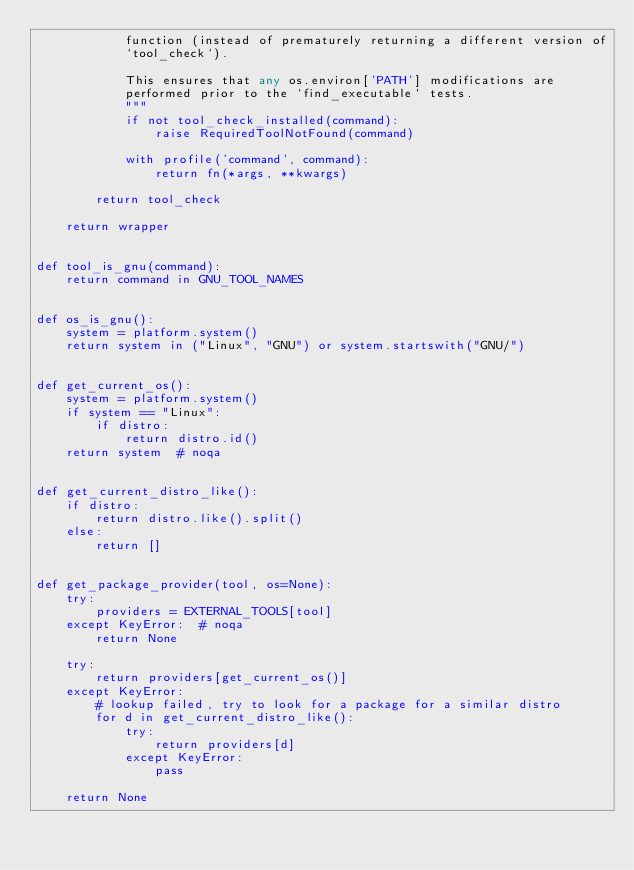Convert code to text. <code><loc_0><loc_0><loc_500><loc_500><_Python_>            function (instead of prematurely returning a different version of
            `tool_check`).

            This ensures that any os.environ['PATH'] modifications are
            performed prior to the `find_executable` tests.
            """
            if not tool_check_installed(command):
                raise RequiredToolNotFound(command)

            with profile('command', command):
                return fn(*args, **kwargs)

        return tool_check

    return wrapper


def tool_is_gnu(command):
    return command in GNU_TOOL_NAMES


def os_is_gnu():
    system = platform.system()
    return system in ("Linux", "GNU") or system.startswith("GNU/")


def get_current_os():
    system = platform.system()
    if system == "Linux":
        if distro:
            return distro.id()
    return system  # noqa


def get_current_distro_like():
    if distro:
        return distro.like().split()
    else:
        return []


def get_package_provider(tool, os=None):
    try:
        providers = EXTERNAL_TOOLS[tool]
    except KeyError:  # noqa
        return None

    try:
        return providers[get_current_os()]
    except KeyError:
        # lookup failed, try to look for a package for a similar distro
        for d in get_current_distro_like():
            try:
                return providers[d]
            except KeyError:
                pass

    return None
</code> 